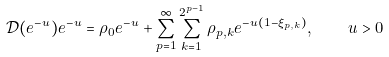Convert formula to latex. <formula><loc_0><loc_0><loc_500><loc_500>\mathcal { D } ( e ^ { - u } ) e ^ { - u } = \rho _ { 0 } e ^ { - u } + \sum _ { p = 1 } ^ { \infty } \sum _ { k = 1 } ^ { 2 ^ { p - 1 } } \rho _ { p , k } e ^ { - u ( 1 - \xi _ { p , k } ) } , \quad u > 0</formula> 